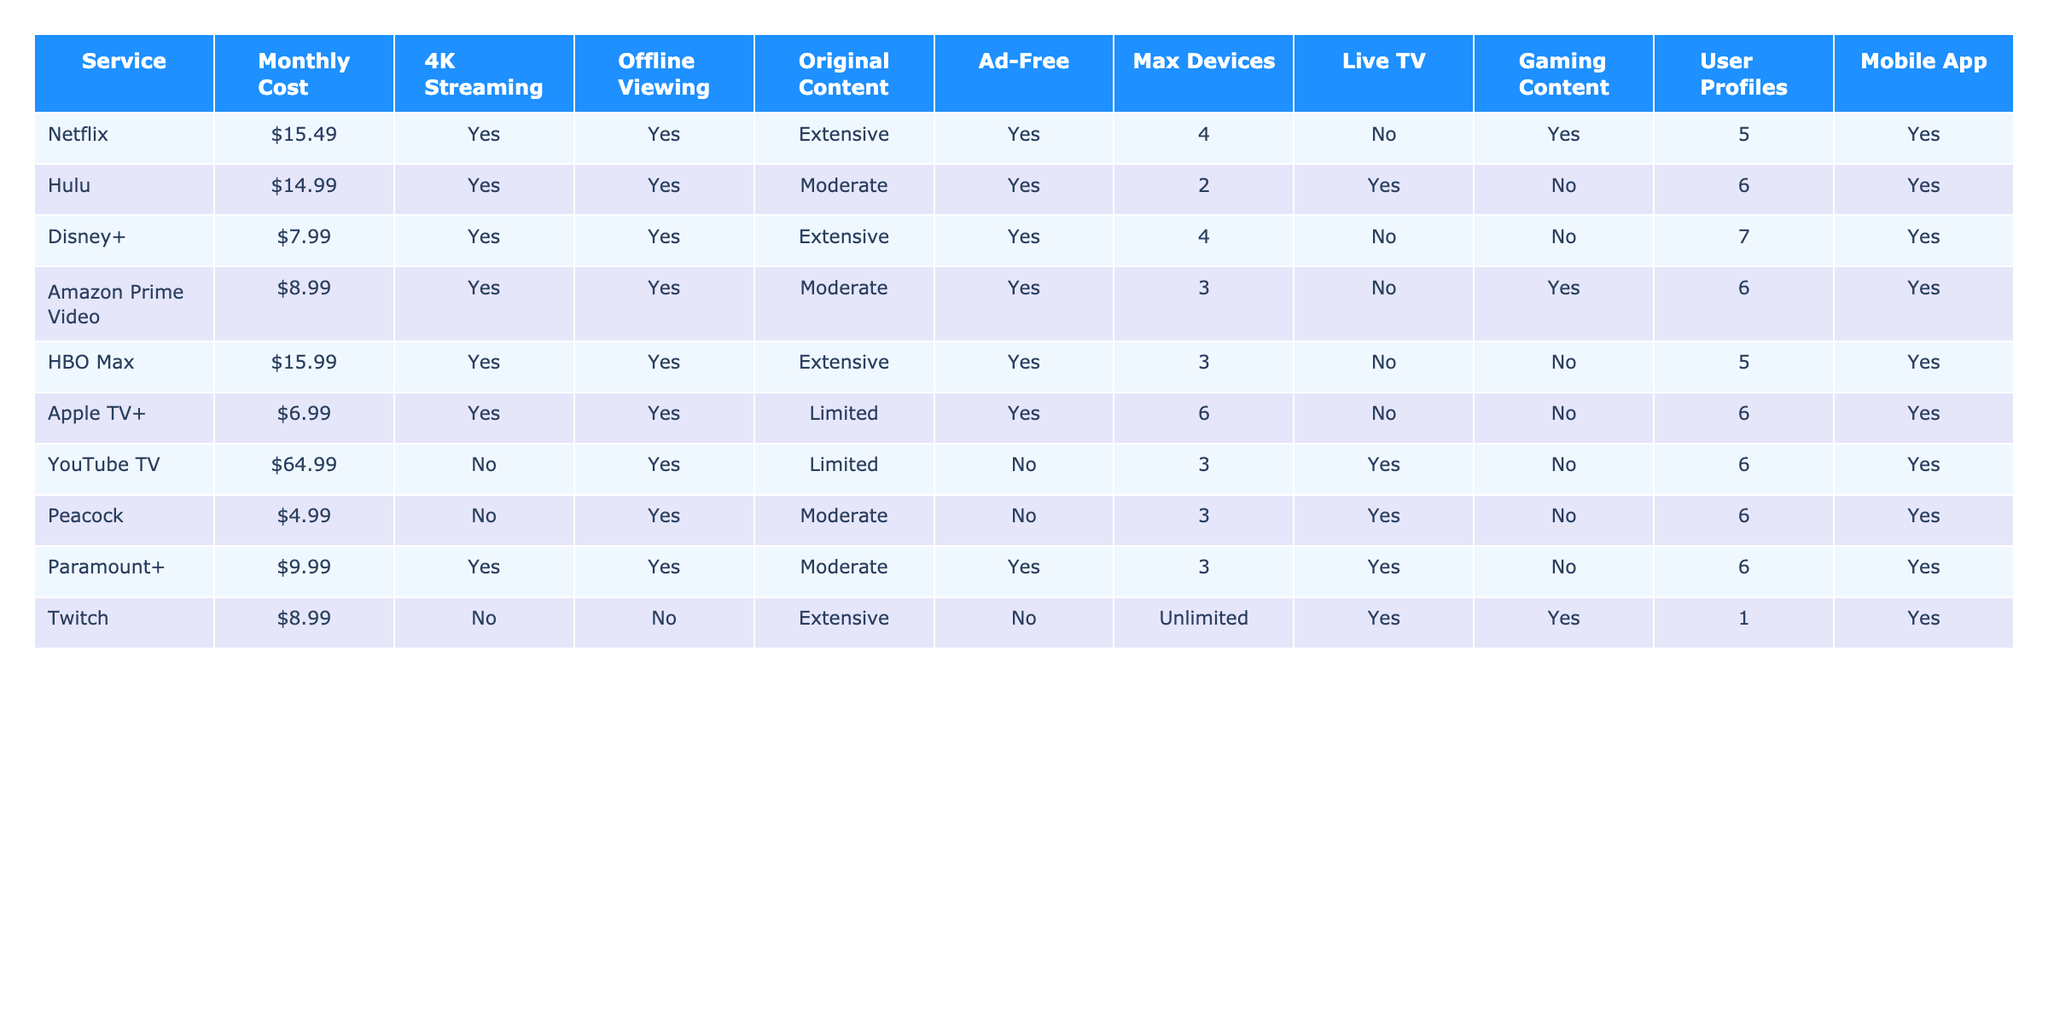What is the monthly cost of Hulu? The table lists Hulu's monthly cost under the "Monthly Cost" column, which shows $14.99.
Answer: $14.99 Which services offer 4K streaming? By checking the "4K Streaming" column, we can see that Netflix, Hulu, Disney+, Amazon Prime Video, HBO Max, and Apple TV+ all offer 4K streaming.
Answer: Netflix, Hulu, Disney+, Amazon Prime Video, HBO Max, Apple TV+ What is the maximum number of devices allowed on Netflix? The "Max Devices" column shows that Netflix allows up to 4 devices simultaneously.
Answer: 4 Is YouTube TV ad-free? The table indicates that YouTube TV is marked as "No" under the "Ad-Free" column.
Answer: No Which streaming service has the highest monthly cost? By comparing the values in the "Monthly Cost" column, we find that YouTube TV at $64.99 has the highest cost.
Answer: YouTube TV How many services offer offline viewing? By reviewing the "Offline Viewing" column, we can count the services that have "Yes" marked, which total to 9 services.
Answer: 9 Does Amazon Prime Video provide live TV? According to the "Live TV" column, Amazon Prime Video has "No" indicated for live TV.
Answer: No If I wanted the most original content for the lowest monthly cost, which service should I choose? By examining the "Original Content" column and the "Monthly Cost" column, the best choice is Amazon Prime Video with moderate original content at $8.99.
Answer: Amazon Prime Video Which service allows the most user profiles? Reviewing the "User Profiles" column, we see that Disney+ permits the most user profiles with a count of 7.
Answer: Disney+ What is the combined monthly cost of Hulu, Amazon Prime Video, and Peacock? Adding the monthly costs of these services ($14.99 for Hulu, $8.99 for Amazon Prime Video, and $4.99 for Peacock) gives us $28.97.
Answer: $28.97 Which service allows unlimited devices but does not support offline viewing? Looking at the "Max Devices" and "Offline Viewing" columns, Twitch is the only service that allows unlimited devices and has "No" for offline viewing.
Answer: Twitch What is the total number of devices supported by all services combined? To find the total number of devices, we sum the values from the "Max Devices" column: 4 (Netflix) + 2 (Hulu) + 4 (Disney+) + 3 (Amazon Prime Video) + 3 (HBO Max) + 6 (Apple TV+) + 3 (YouTube TV) + 3 (Peacock) + 3 (Paramount+) + Unlimited (Twitch, considered as a maximum of 10 for calculation). This results in a total of 32 devices (or 37 if we do not cap unlimited).
Answer: 32 or 37 How many services include live TV and allow offline viewing? By checking both the "Live TV" and "Offline Viewing" columns, we find that 5 services (Hulu, Amazon Prime Video, Paramount+, YouTube TV, and Peacock) meet both criteria.
Answer: 5 